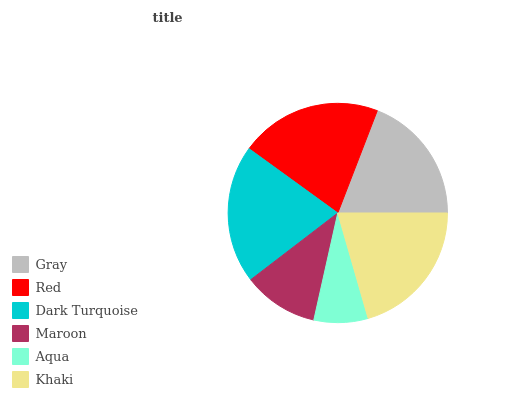Is Aqua the minimum?
Answer yes or no. Yes. Is Red the maximum?
Answer yes or no. Yes. Is Dark Turquoise the minimum?
Answer yes or no. No. Is Dark Turquoise the maximum?
Answer yes or no. No. Is Red greater than Dark Turquoise?
Answer yes or no. Yes. Is Dark Turquoise less than Red?
Answer yes or no. Yes. Is Dark Turquoise greater than Red?
Answer yes or no. No. Is Red less than Dark Turquoise?
Answer yes or no. No. Is Dark Turquoise the high median?
Answer yes or no. Yes. Is Gray the low median?
Answer yes or no. Yes. Is Red the high median?
Answer yes or no. No. Is Maroon the low median?
Answer yes or no. No. 